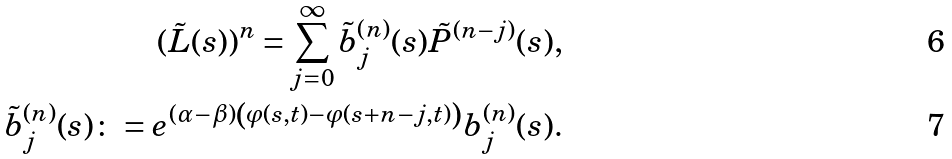<formula> <loc_0><loc_0><loc_500><loc_500>( \tilde { L } ( s ) ) ^ { n } = \sum _ { j = 0 } ^ { \infty } \tilde { b } ^ { ( n ) } _ { j } ( s ) \tilde { P } ^ { ( n - j ) } ( s ) , \\ \tilde { b } ^ { ( n ) } _ { j } ( s ) \colon = e ^ { ( \alpha - \beta ) \left ( \varphi ( s , t ) - \varphi ( s + n - j , t ) \right ) } b ^ { ( n ) } _ { j } ( s ) .</formula> 